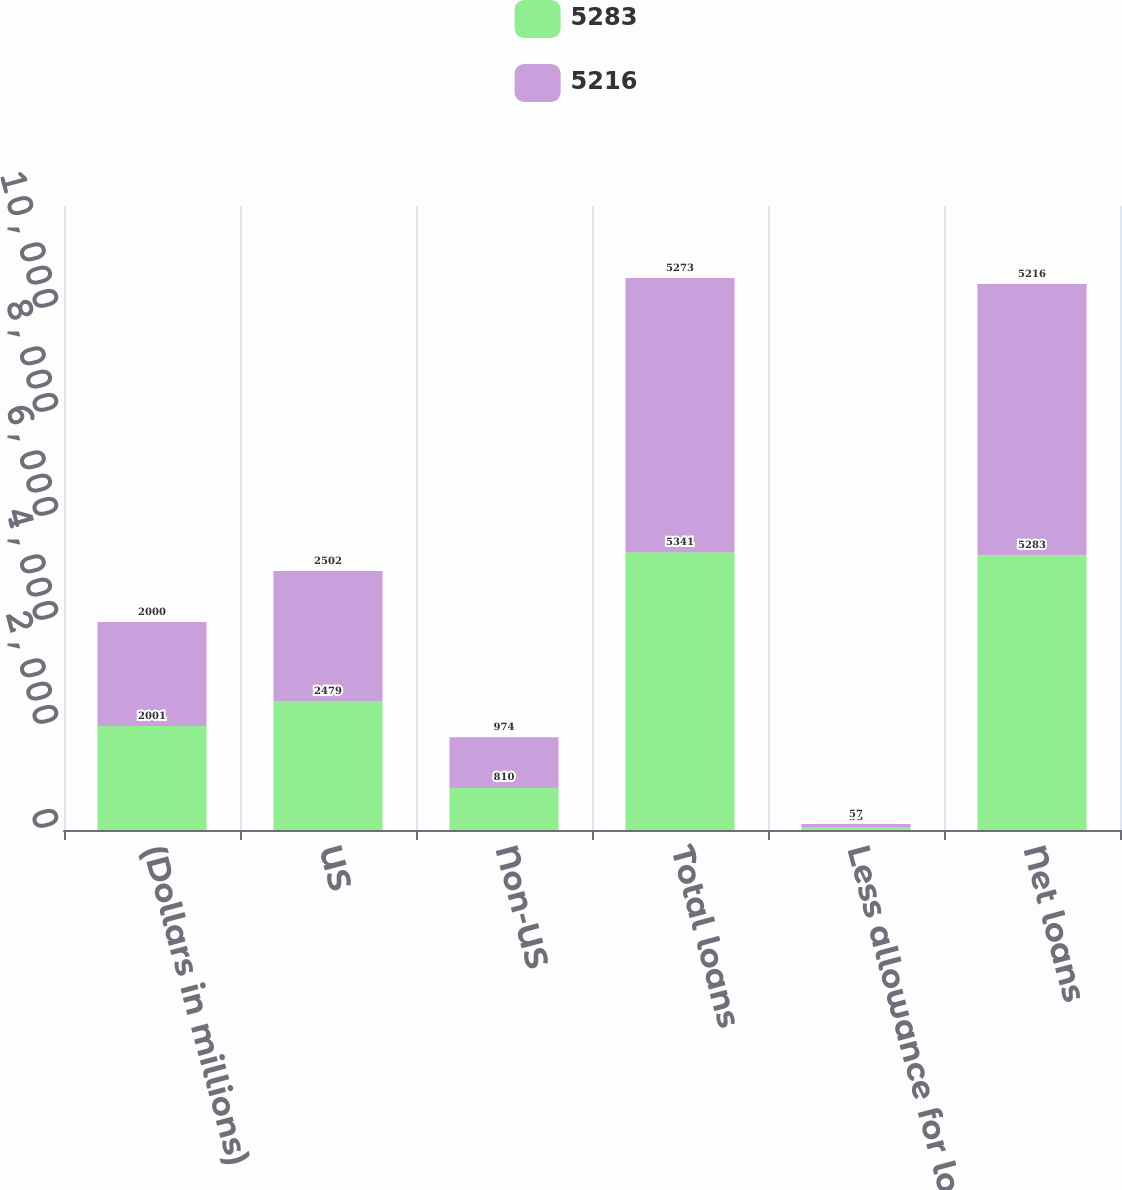Convert chart. <chart><loc_0><loc_0><loc_500><loc_500><stacked_bar_chart><ecel><fcel>(Dollars in millions)<fcel>US<fcel>Non-US<fcel>Total loans<fcel>Less allowance for loan losses<fcel>Net loans<nl><fcel>5283<fcel>2001<fcel>2479<fcel>810<fcel>5341<fcel>58<fcel>5283<nl><fcel>5216<fcel>2000<fcel>2502<fcel>974<fcel>5273<fcel>57<fcel>5216<nl></chart> 